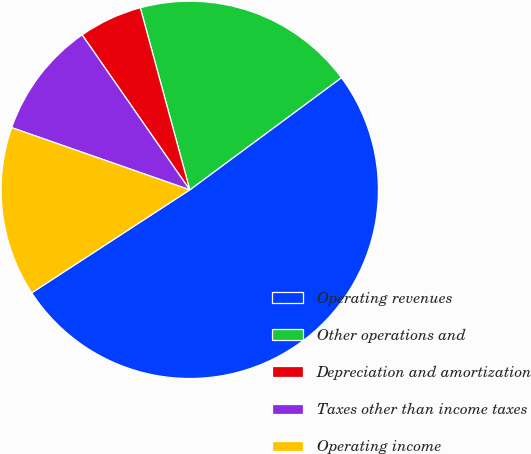Convert chart to OTSL. <chart><loc_0><loc_0><loc_500><loc_500><pie_chart><fcel>Operating revenues<fcel>Other operations and<fcel>Depreciation and amortization<fcel>Taxes other than income taxes<fcel>Operating income<nl><fcel>50.95%<fcel>19.09%<fcel>5.44%<fcel>9.99%<fcel>14.54%<nl></chart> 